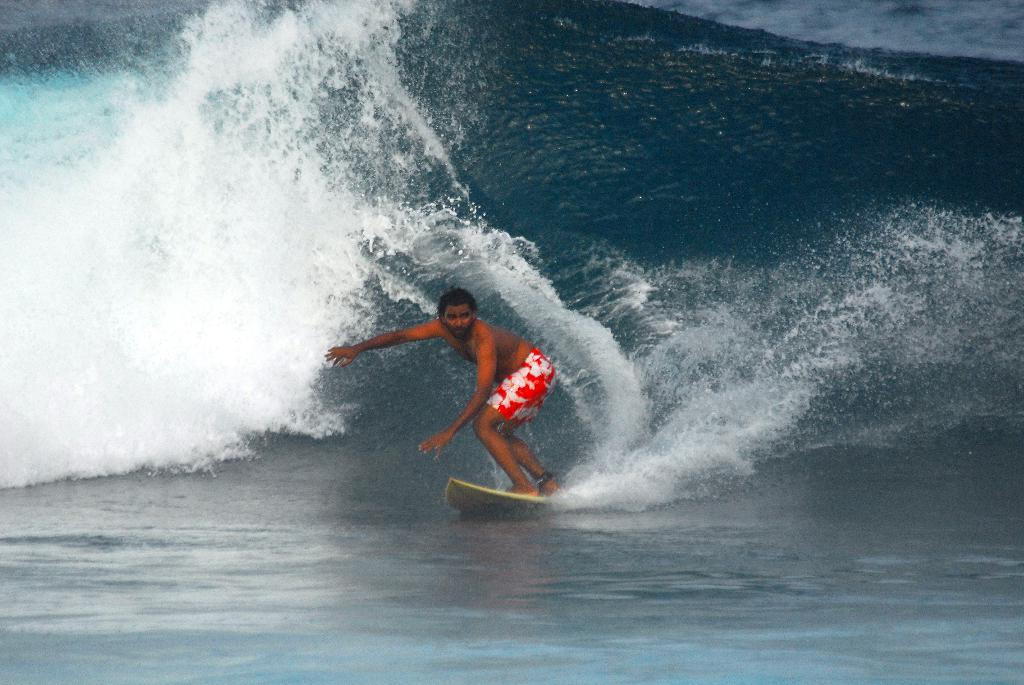Who is the main subject in the image? There is a man in the image. What is the man doing in the image? The man is surfing on a surfboard. What type of environment is visible in the image? There is water visible in the image. Where is the button located on the surfboard in the image? There is no button present on the surfboard in the image. What type of flame can be seen coming from the man's feet while he is surfing? There is no flame visible in the image; the man is surfing on water. 